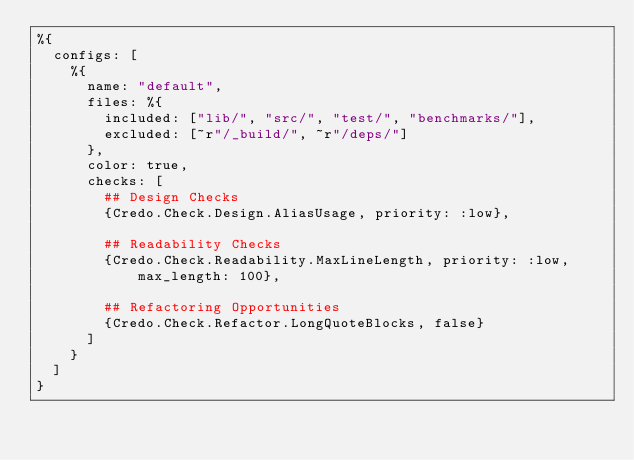<code> <loc_0><loc_0><loc_500><loc_500><_Elixir_>%{
  configs: [
    %{
      name: "default",
      files: %{
        included: ["lib/", "src/", "test/", "benchmarks/"],
        excluded: [~r"/_build/", ~r"/deps/"]
      },
      color: true,
      checks: [
        ## Design Checks
        {Credo.Check.Design.AliasUsage, priority: :low},

        ## Readability Checks
        {Credo.Check.Readability.MaxLineLength, priority: :low, max_length: 100},

        ## Refactoring Opportunities
        {Credo.Check.Refactor.LongQuoteBlocks, false}
      ]
    }
  ]
}
</code> 